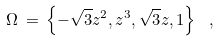Convert formula to latex. <formula><loc_0><loc_0><loc_500><loc_500>\Omega \, = \, \left \{ - \sqrt { 3 } z ^ { 2 } , z ^ { 3 } , \sqrt { 3 } z , 1 \right \} \ ,</formula> 